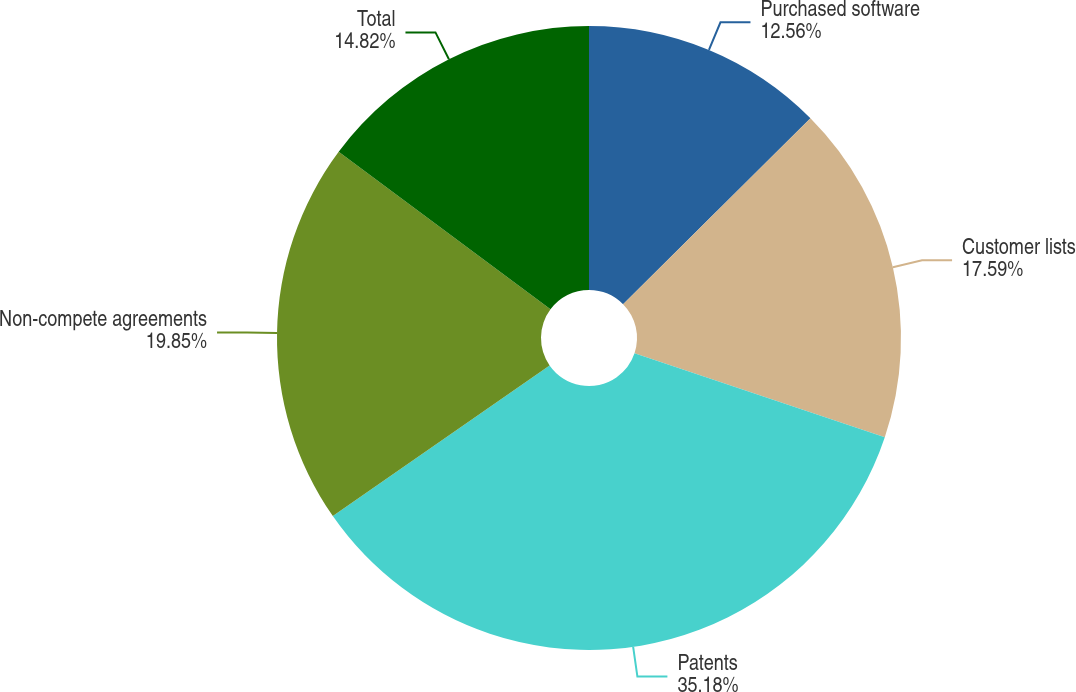Convert chart. <chart><loc_0><loc_0><loc_500><loc_500><pie_chart><fcel>Purchased software<fcel>Customer lists<fcel>Patents<fcel>Non-compete agreements<fcel>Total<nl><fcel>12.56%<fcel>17.59%<fcel>35.18%<fcel>19.85%<fcel>14.82%<nl></chart> 